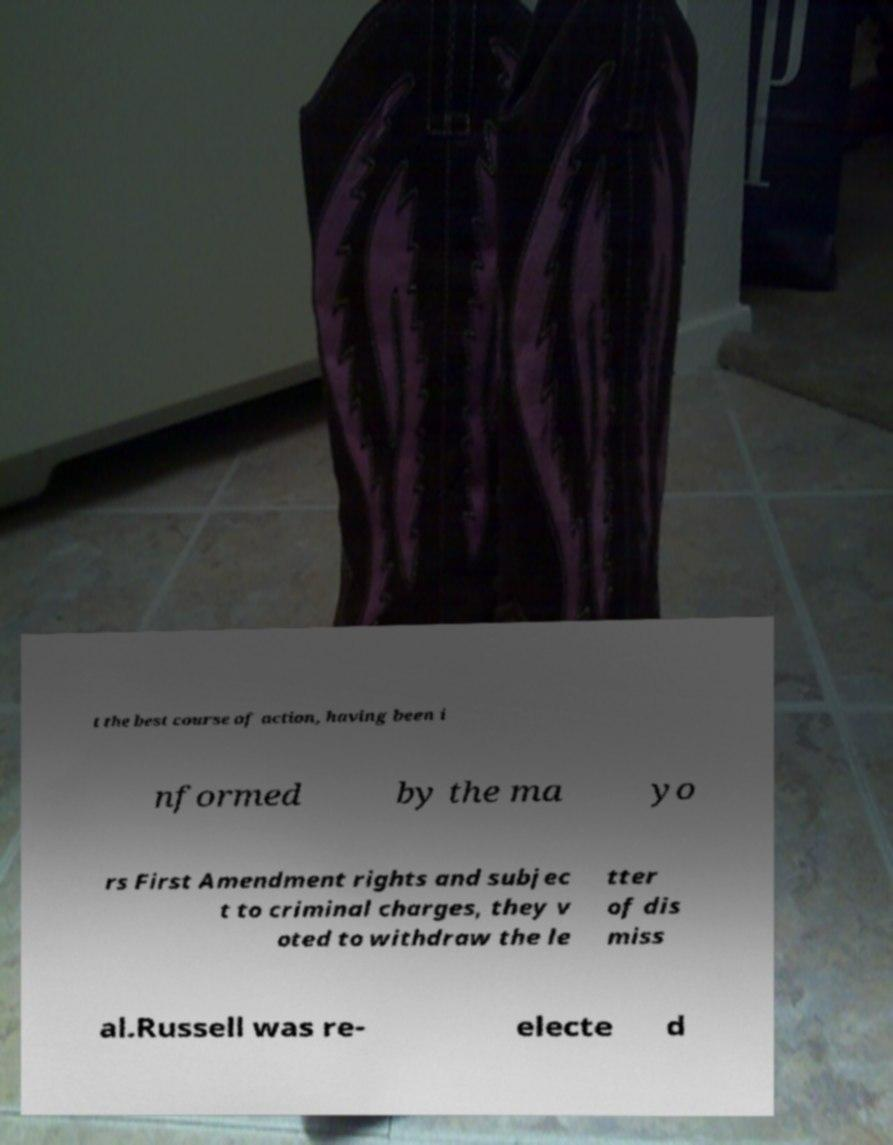Please identify and transcribe the text found in this image. t the best course of action, having been i nformed by the ma yo rs First Amendment rights and subjec t to criminal charges, they v oted to withdraw the le tter of dis miss al.Russell was re- electe d 